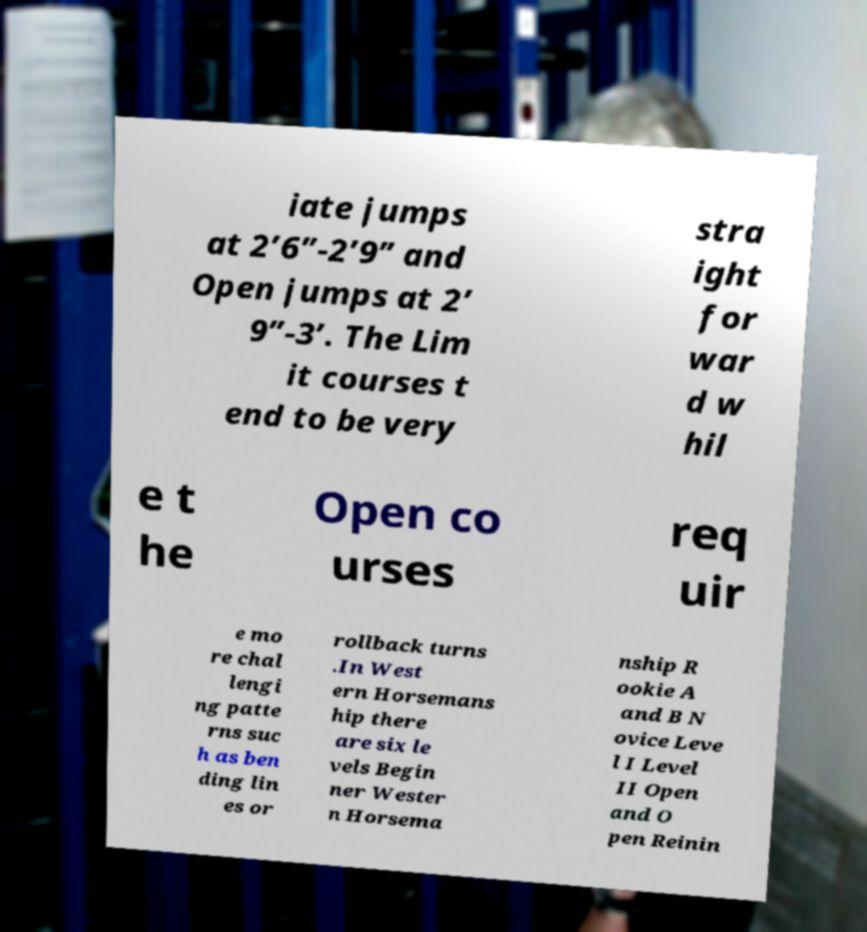I need the written content from this picture converted into text. Can you do that? iate jumps at 2’6”-2’9” and Open jumps at 2’ 9”-3’. The Lim it courses t end to be very stra ight for war d w hil e t he Open co urses req uir e mo re chal lengi ng patte rns suc h as ben ding lin es or rollback turns .In West ern Horsemans hip there are six le vels Begin ner Wester n Horsema nship R ookie A and B N ovice Leve l I Level II Open and O pen Reinin 